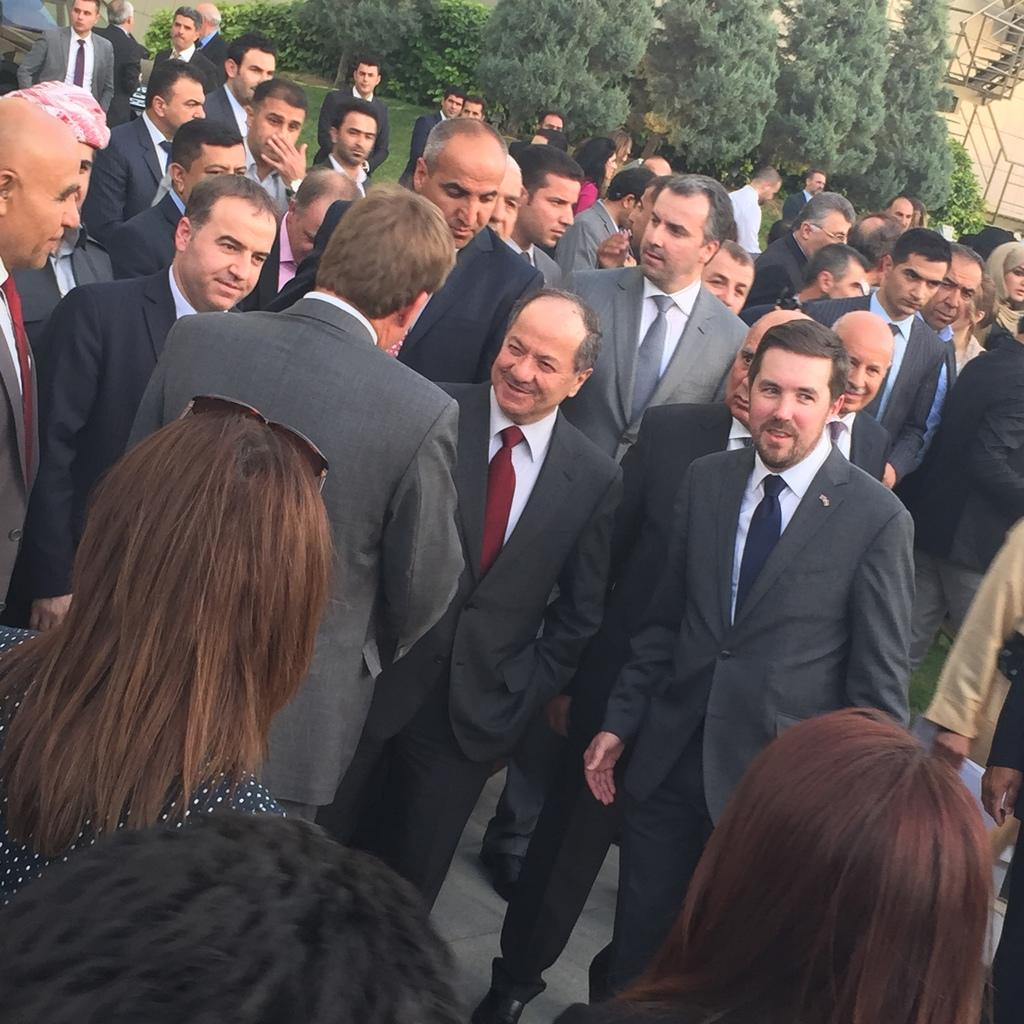What type of clothing are most of the men wearing in the image? Most of the men in the image are wearing suits. Can you describe the women in the image? Some women are visible in the image. What can be seen in the background of the image? There are trees and at least one building in the background of the image. What type of tank can be seen in the image? There is no tank present in the image. Can you describe the squirrel sitting on the woman's shoulder in the image? There is no squirrel visible in the image. 